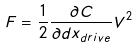Convert formula to latex. <formula><loc_0><loc_0><loc_500><loc_500>F = \frac { 1 } { 2 } \frac { \partial C } { \partial d x _ { d r i v e } } V ^ { 2 }</formula> 